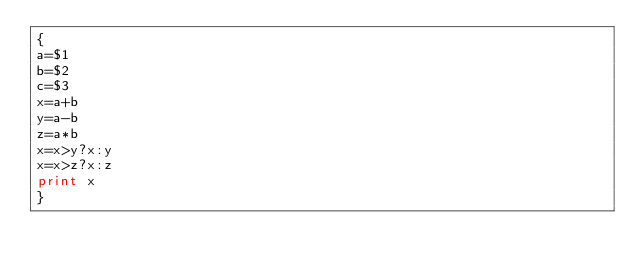Convert code to text. <code><loc_0><loc_0><loc_500><loc_500><_Awk_>{
a=$1
b=$2
c=$3
x=a+b
y=a-b
z=a*b
x=x>y?x:y
x=x>z?x:z
print x
}</code> 